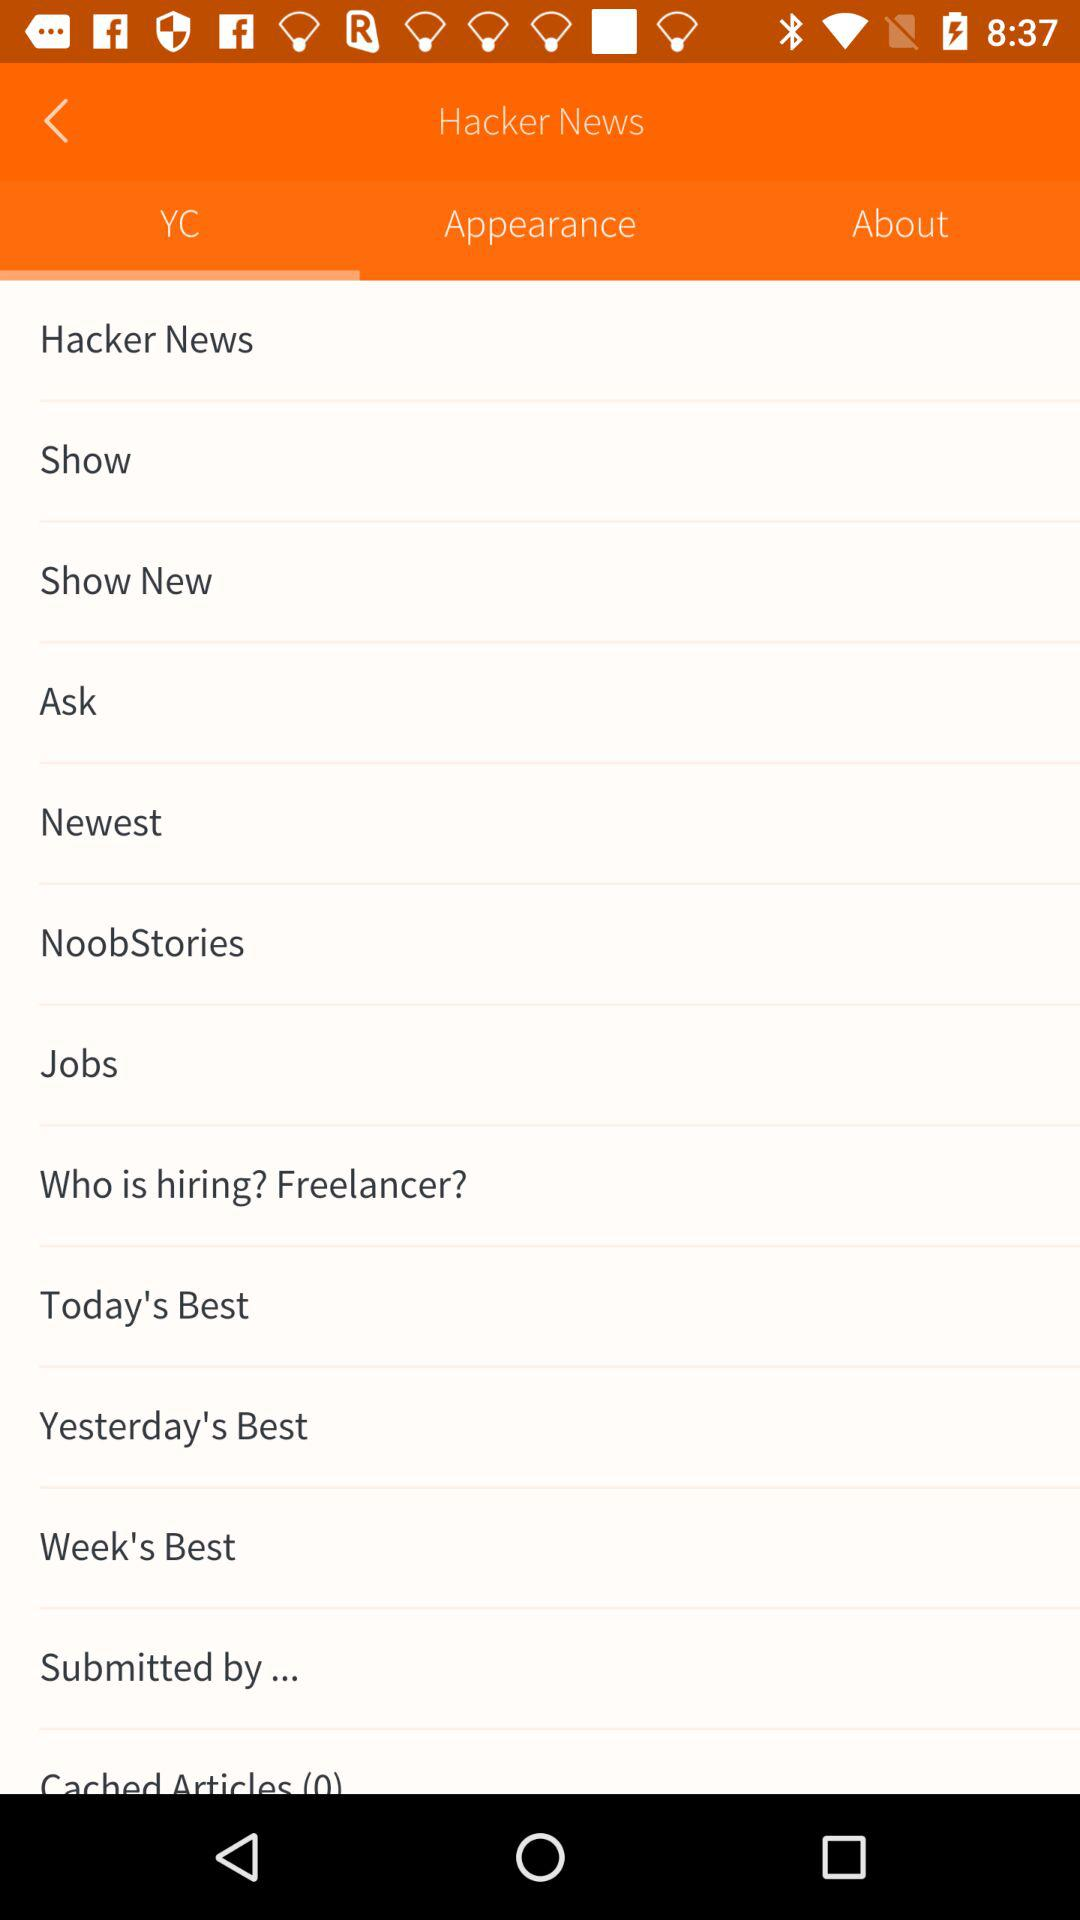Which is the selected tab? The selected tab is "YC". 